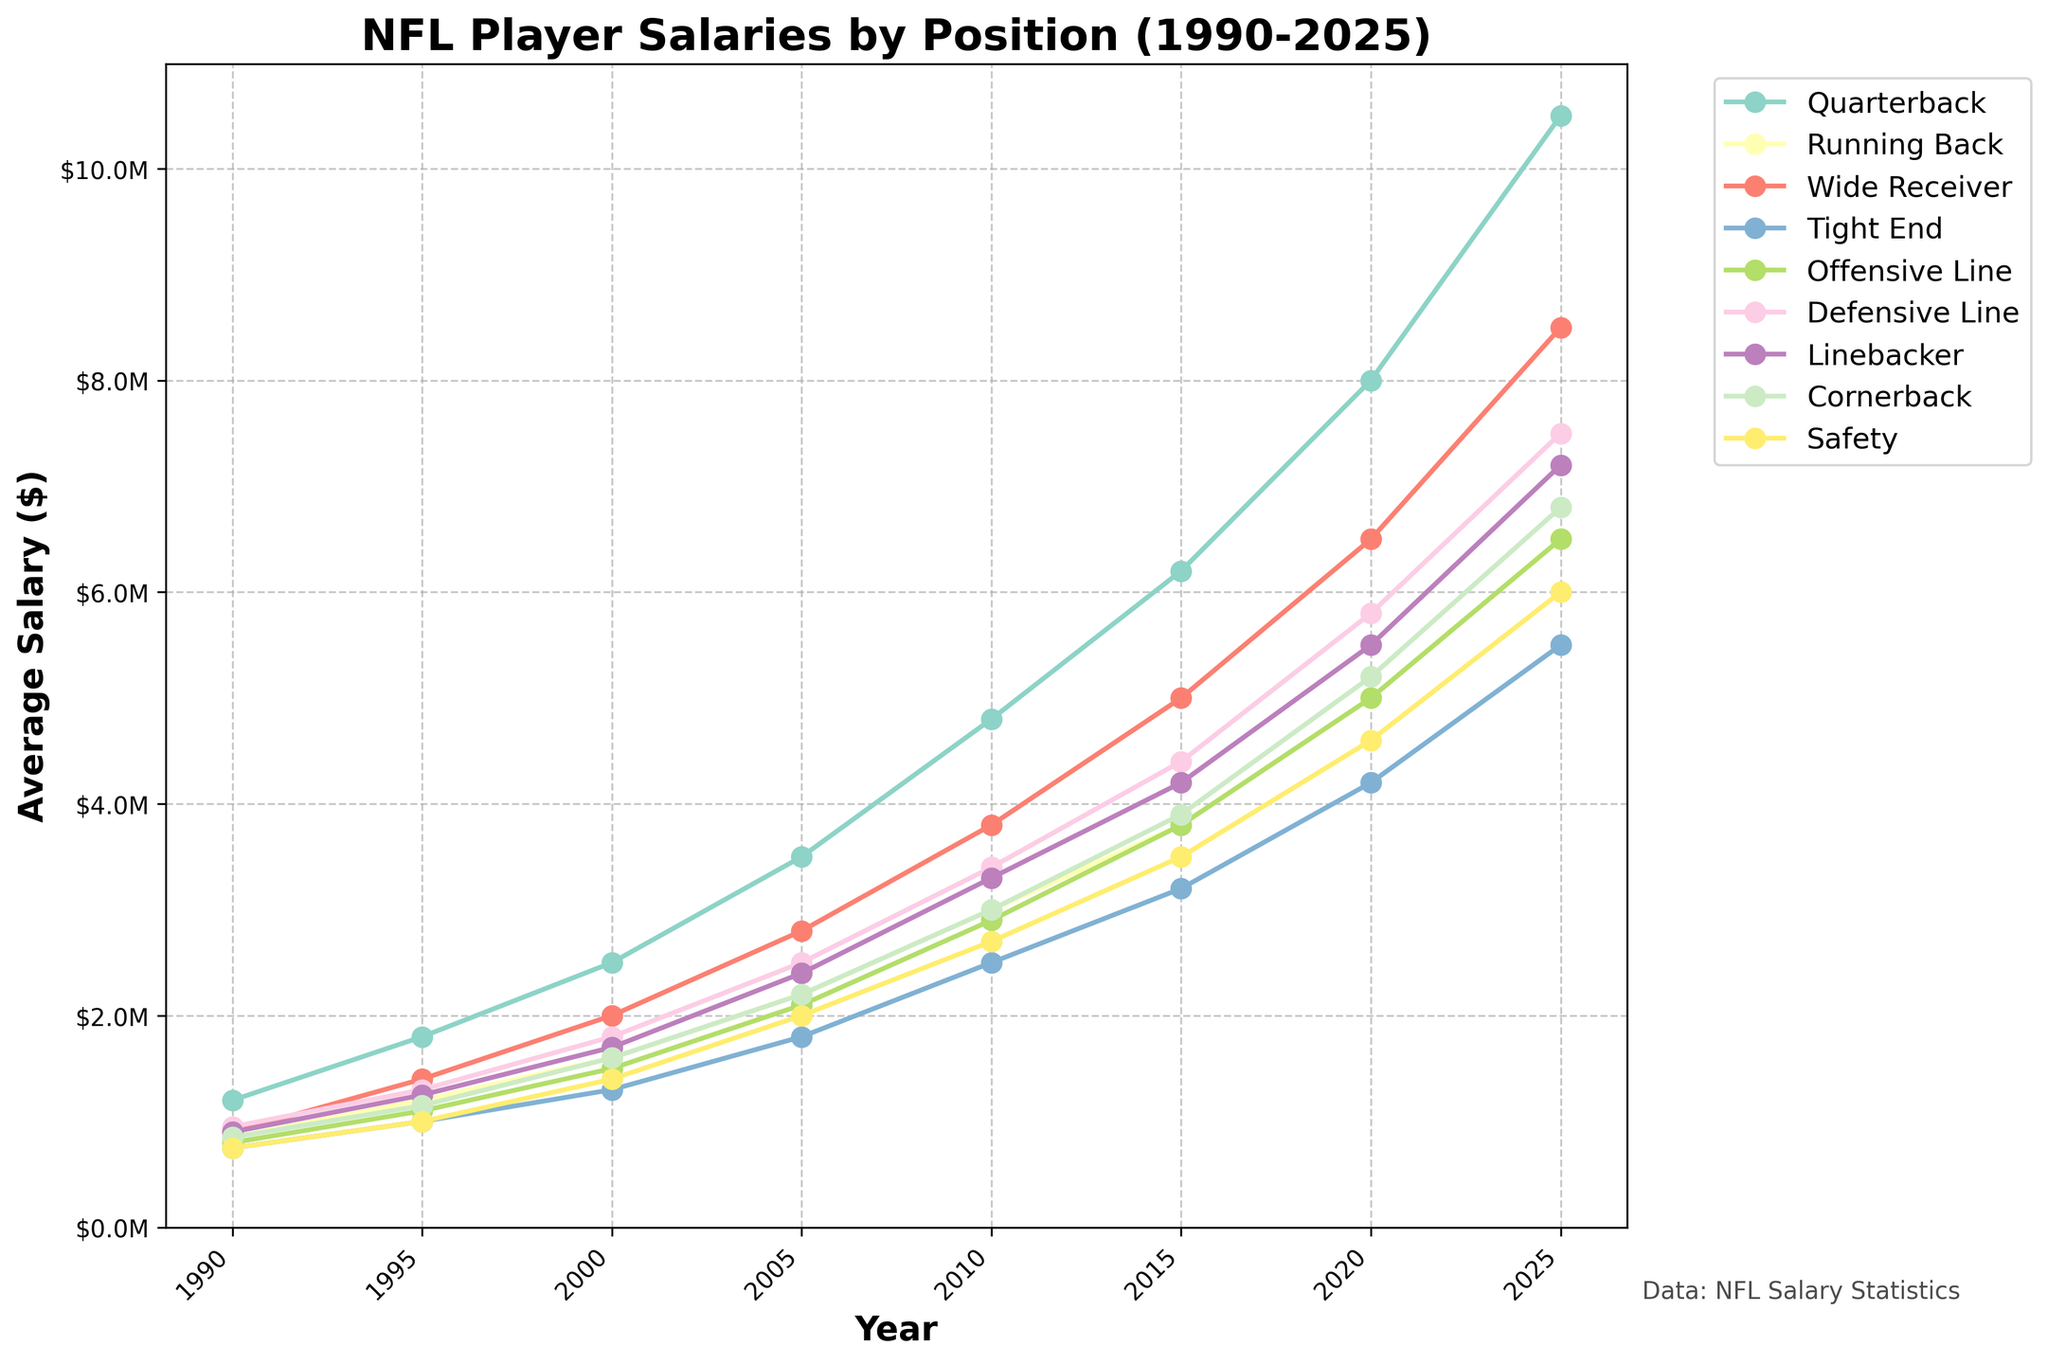What's the average salary of a Linebacker in 2020 and 2025? In 2020, the salary is $5,500,000 and in 2025, the salary is $7,200,000. The average is calculated as (5500000 + 7200000) / 2.
Answer: $6,350,000 Which position had the highest salary in 1990? By looking at the 1990 data points, the Quarterback had the highest salary of $1,200,000.
Answer: Quarterback Between Wide Receiver and Tight End, which position saw a bigger increase in average salary from 1990 to 2025? The Wide Receiver salary increased from $900,000 in 1990 to $8,500,000 in 2025, a difference of $7,600,000. The Tight End salary increased from $750,000 in 1990 to $5,500,000 in 2025, a difference of $4,750,000.
Answer: Wide Receiver What is the total salary for Offensive Line in 1995 and 2000 combined? In 1995 the salary is $1,100,000 and in 2000 it's $1,500,000, the total is $1,100,000 + $1,500,000.
Answer: $2,600,000 How does the salary trend for Quarterbacks compare visually to that of Running Backs? Quarterback salaries show a steeper upward trend visually compared to Running Back salaries, which have a gentler slope.
Answer: Steeper upward trend Which position had the smallest growth in average salary from 1990 to 2025? By comparing the growth of all positions from 1990 to 2025, the Tight End's salary increased from $750,000 to $5,500,000. This is $4,750,000, which is the smallest increment.
Answer: Tight End By how much did the average salary for a Defensive Line player increase from 2000 to 2025? Defensive Line salary in 2000 was $1,800,000 and in 2025 it is $7,500,000; the difference is $7,500,000 - $1,800,000.
Answer: $5,700,000 Which year had the biggest increase in salary for Running Backs compared to the previous recorded year? Comparing year by year, from 2015 to 2020 the increase is $5,000,000 - $3,800,000 = $1,200,000, which is the largest increment.
Answer: 2020 What is the percentage increase in average salary for Wide Receivers from 2010 to 2025? In 2010, Wide Receiver salary is $3,800,000 and in 2025 it’s $8,500,000. The percentage increase is calculated as ((8,500,000 - 3,800,000) / 3,800,000) * 100.
Answer: 123.68% Which position has the least variation in salary over the years, visually? By inspecting the visual trends, the Safety position has the least variation as its line appears smoother with fewer sharp changes.
Answer: Safety 